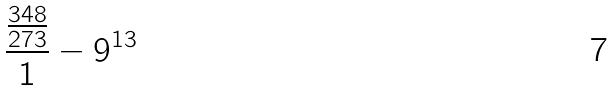Convert formula to latex. <formula><loc_0><loc_0><loc_500><loc_500>\frac { \frac { 3 4 8 } { 2 7 3 } } { 1 } - 9 ^ { 1 3 }</formula> 